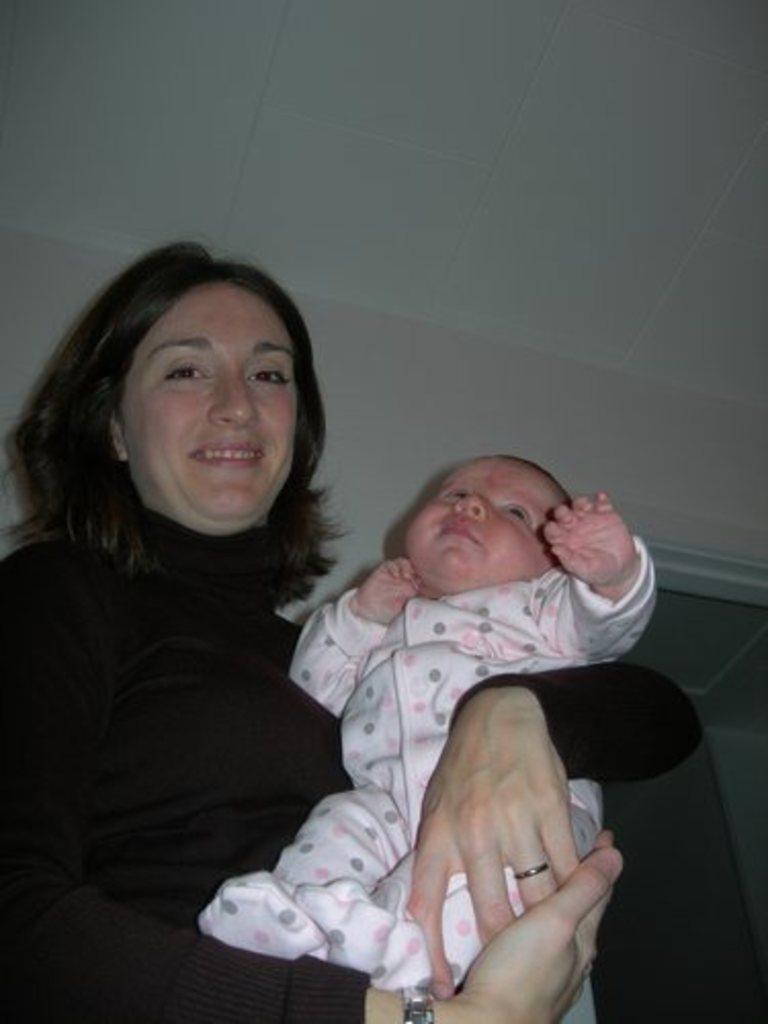Please provide a concise description of this image. This picture is clicked inside. On the left there is a woman wearing a black color dress, smiling, seems to be sitting on the chair and holding a baby and the baby is wearing white color dress. In the background we can see the roof and the ground. 